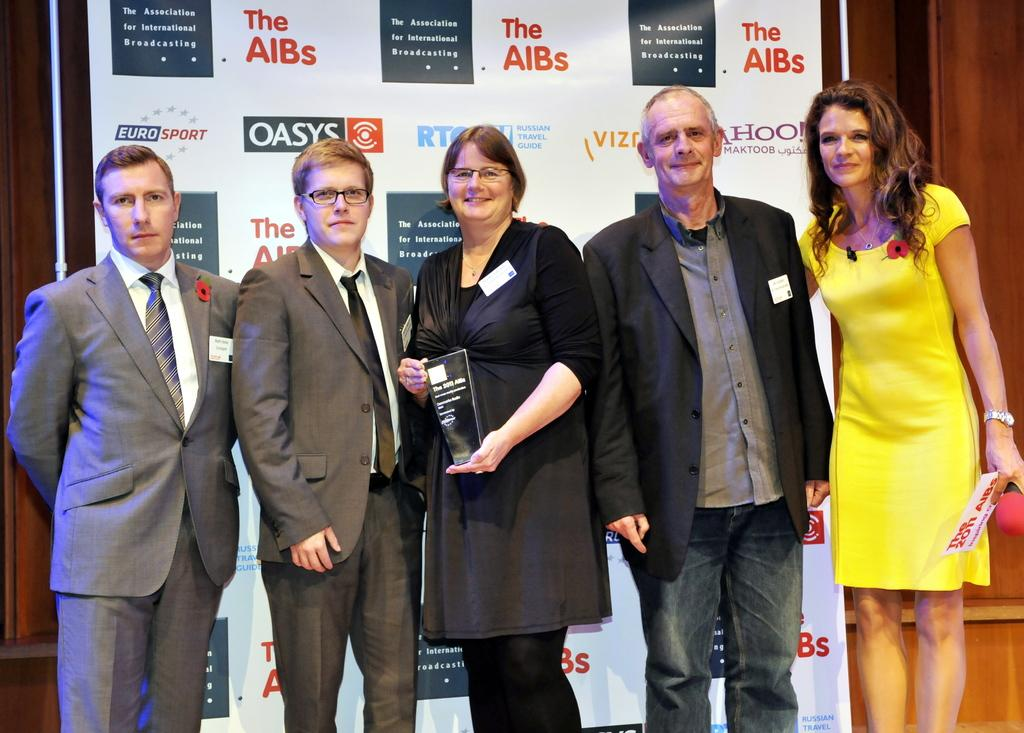How many people are in the image? There is a group of persons in the image. What are the persons in the image doing? The persons are standing on the floor. What can be seen in the background of the image? There is an advertisement and a wall in the background of the image. What is the income of the persons in the image? There is no information about the income of the persons in the image. Are the persons in the image driving a vehicle? There is no indication of a vehicle or driving in the image. 